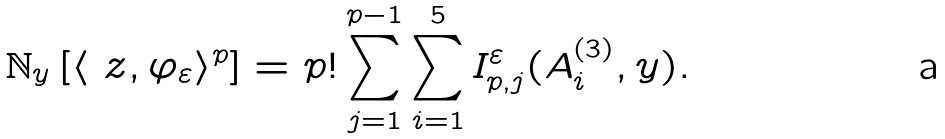<formula> <loc_0><loc_0><loc_500><loc_500>\mathbb { N } _ { y } \left [ \langle \ z , \varphi _ { \varepsilon } \rangle ^ { p } \right ] = p ! \sum _ { j = 1 } ^ { p - 1 } \sum _ { i = 1 } ^ { 5 } I ^ { \varepsilon } _ { p , j } ( A _ { i } ^ { ( 3 ) } , y ) .</formula> 